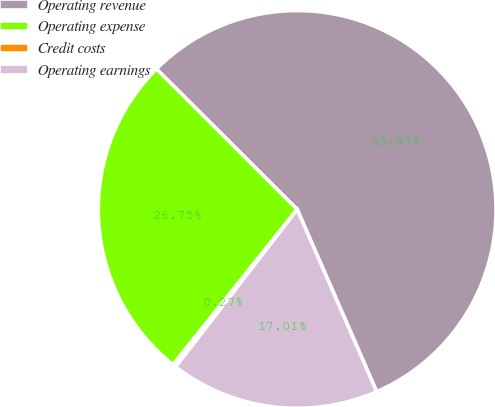Convert chart. <chart><loc_0><loc_0><loc_500><loc_500><pie_chart><fcel>Operating revenue<fcel>Operating expense<fcel>Credit costs<fcel>Operating earnings<nl><fcel>55.97%<fcel>26.75%<fcel>0.27%<fcel>17.01%<nl></chart> 